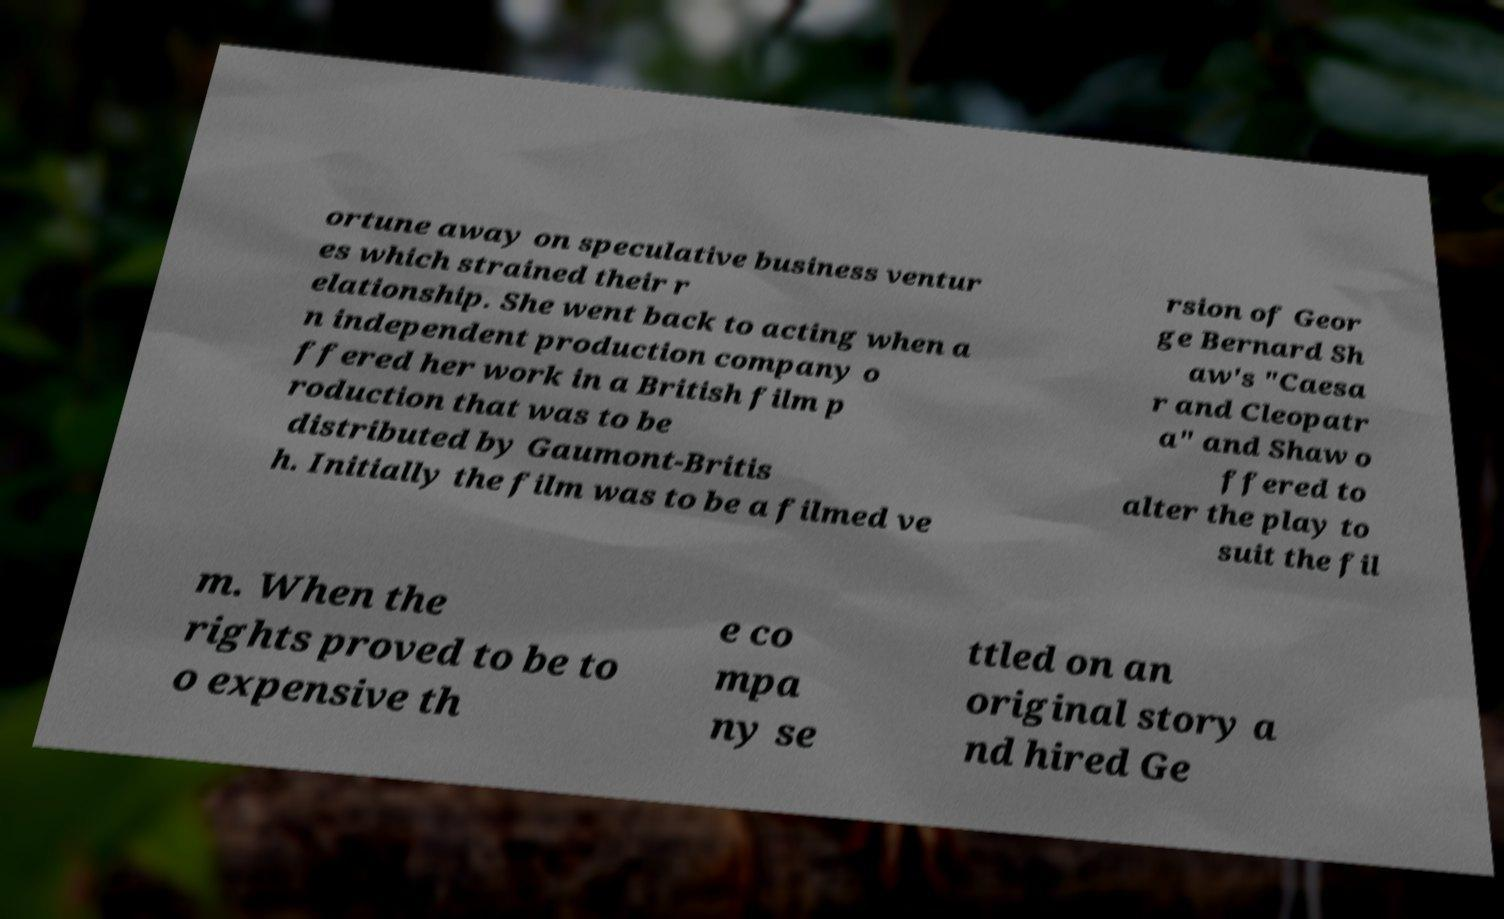Could you assist in decoding the text presented in this image and type it out clearly? ortune away on speculative business ventur es which strained their r elationship. She went back to acting when a n independent production company o ffered her work in a British film p roduction that was to be distributed by Gaumont-Britis h. Initially the film was to be a filmed ve rsion of Geor ge Bernard Sh aw's "Caesa r and Cleopatr a" and Shaw o ffered to alter the play to suit the fil m. When the rights proved to be to o expensive th e co mpa ny se ttled on an original story a nd hired Ge 